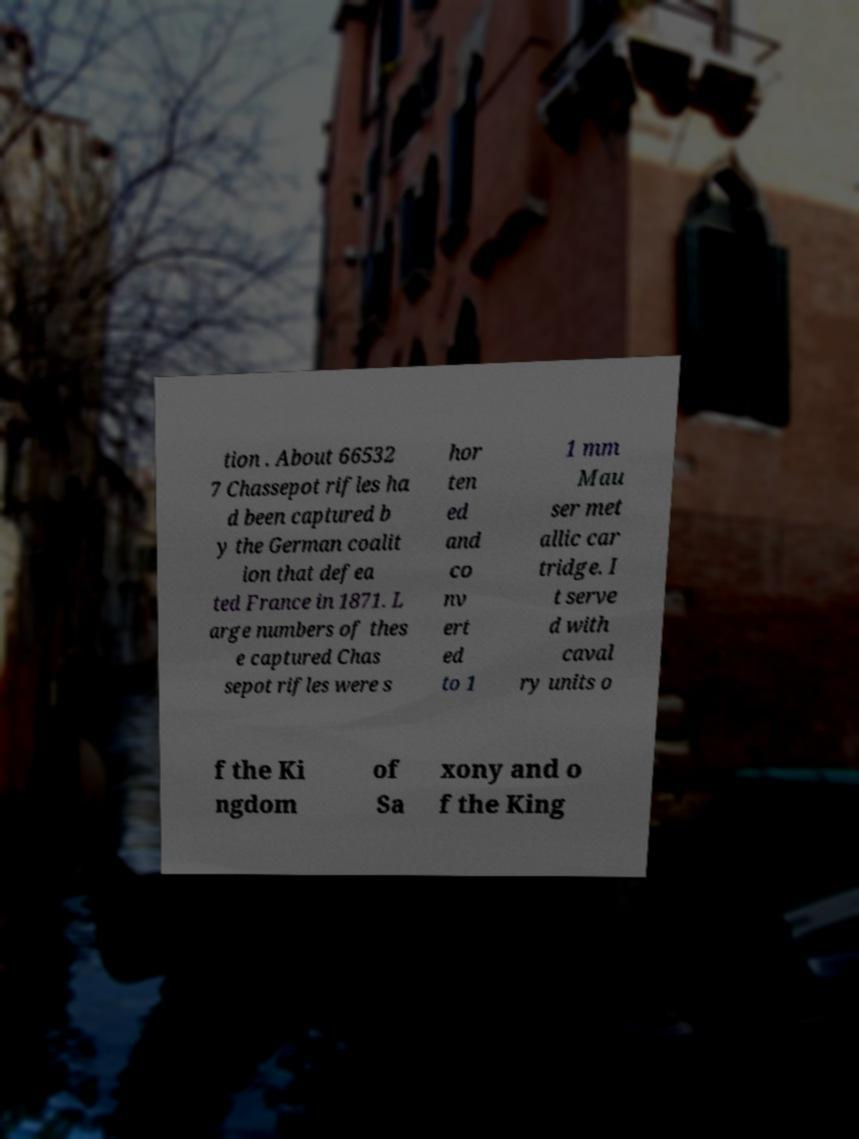Could you extract and type out the text from this image? tion . About 66532 7 Chassepot rifles ha d been captured b y the German coalit ion that defea ted France in 1871. L arge numbers of thes e captured Chas sepot rifles were s hor ten ed and co nv ert ed to 1 1 mm Mau ser met allic car tridge. I t serve d with caval ry units o f the Ki ngdom of Sa xony and o f the King 